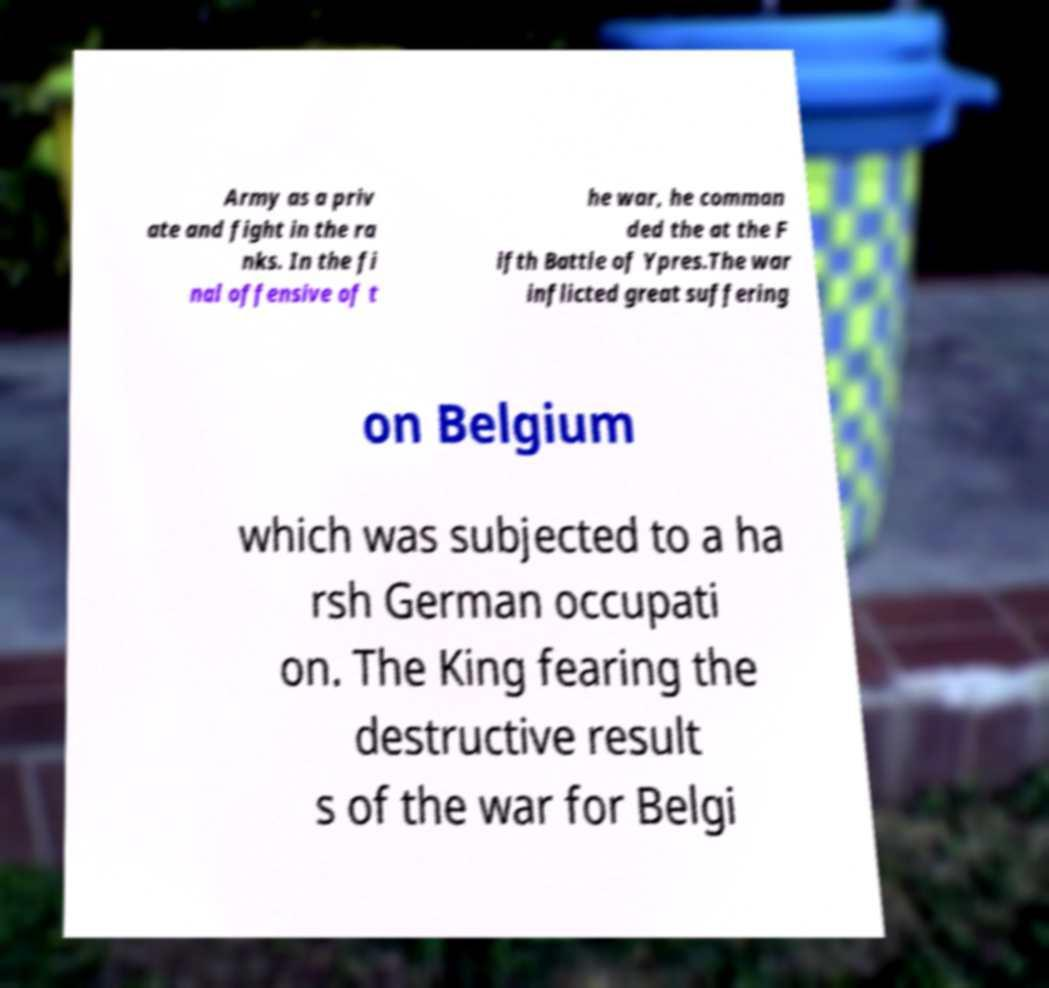Could you assist in decoding the text presented in this image and type it out clearly? Army as a priv ate and fight in the ra nks. In the fi nal offensive of t he war, he comman ded the at the F ifth Battle of Ypres.The war inflicted great suffering on Belgium which was subjected to a ha rsh German occupati on. The King fearing the destructive result s of the war for Belgi 